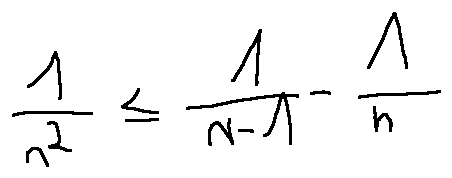<formula> <loc_0><loc_0><loc_500><loc_500>\frac { 1 } { n ^ { 2 } } \leq \frac { 1 } { n - 1 } - \frac { 1 } { n }</formula> 